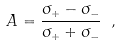Convert formula to latex. <formula><loc_0><loc_0><loc_500><loc_500>A = \frac { \sigma _ { + } - \sigma _ { - } } { \sigma _ { + } + \sigma _ { - } } \ ,</formula> 